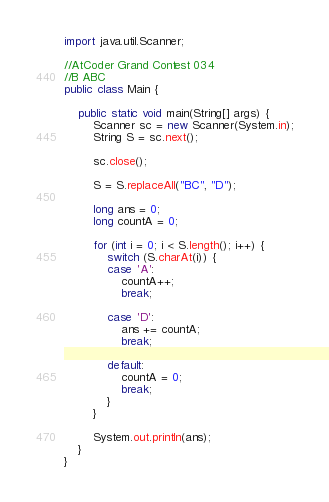<code> <loc_0><loc_0><loc_500><loc_500><_Java_>import java.util.Scanner;

//AtCoder Grand Contest 034
//B	ABC
public class Main {

	public static void main(String[] args) {
		Scanner sc = new Scanner(System.in);
		String S = sc.next();

		sc.close();

		S = S.replaceAll("BC", "D");

		long ans = 0;
		long countA = 0;

		for (int i = 0; i < S.length(); i++) {
			switch (S.charAt(i)) {
			case 'A':
				countA++;
				break;

			case 'D':
				ans += countA;
				break;

			default:
				countA = 0;
				break;
			}
		}

		System.out.println(ans);
	}
}
</code> 